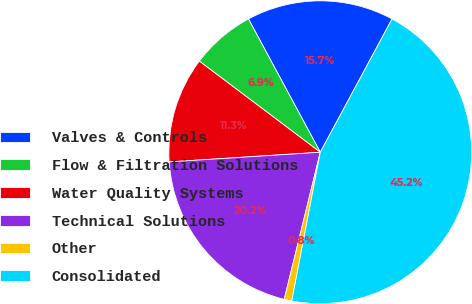Convert chart to OTSL. <chart><loc_0><loc_0><loc_500><loc_500><pie_chart><fcel>Valves & Controls<fcel>Flow & Filtration Solutions<fcel>Water Quality Systems<fcel>Technical Solutions<fcel>Other<fcel>Consolidated<nl><fcel>15.73%<fcel>6.86%<fcel>11.29%<fcel>20.16%<fcel>0.81%<fcel>45.15%<nl></chart> 